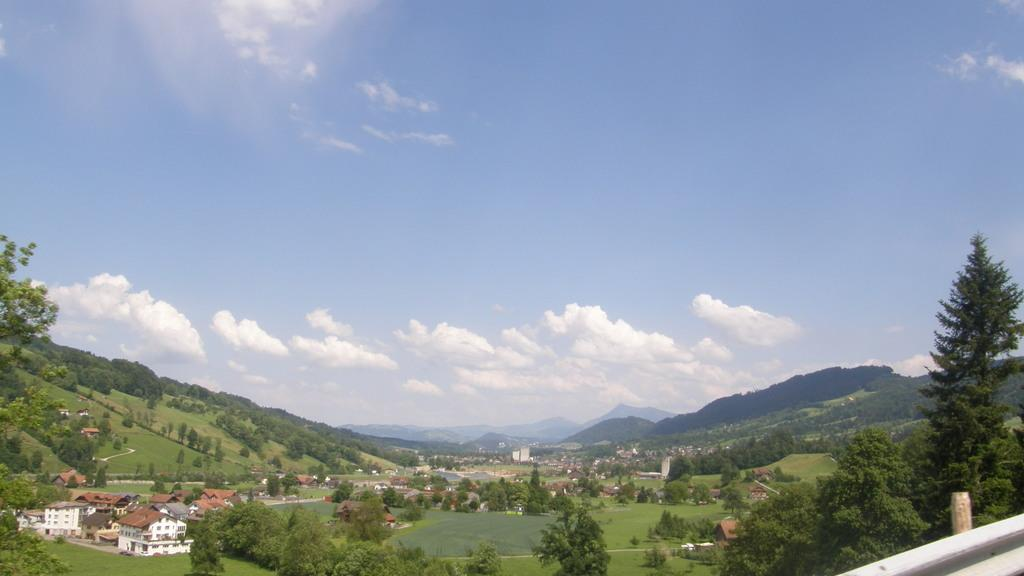What type of vegetation is present in the image? There is grass in the image. What structures can be seen on the left side of the image? There are houses on the left side of the image. What can be seen in the background of the image? There are trees and clouds in the sky in the background of the image. What type of grape is being harvested in the image? There is no grape or harvesting activity present in the image. What day of the week is it in the image? The day of the week cannot be determined from the image. 